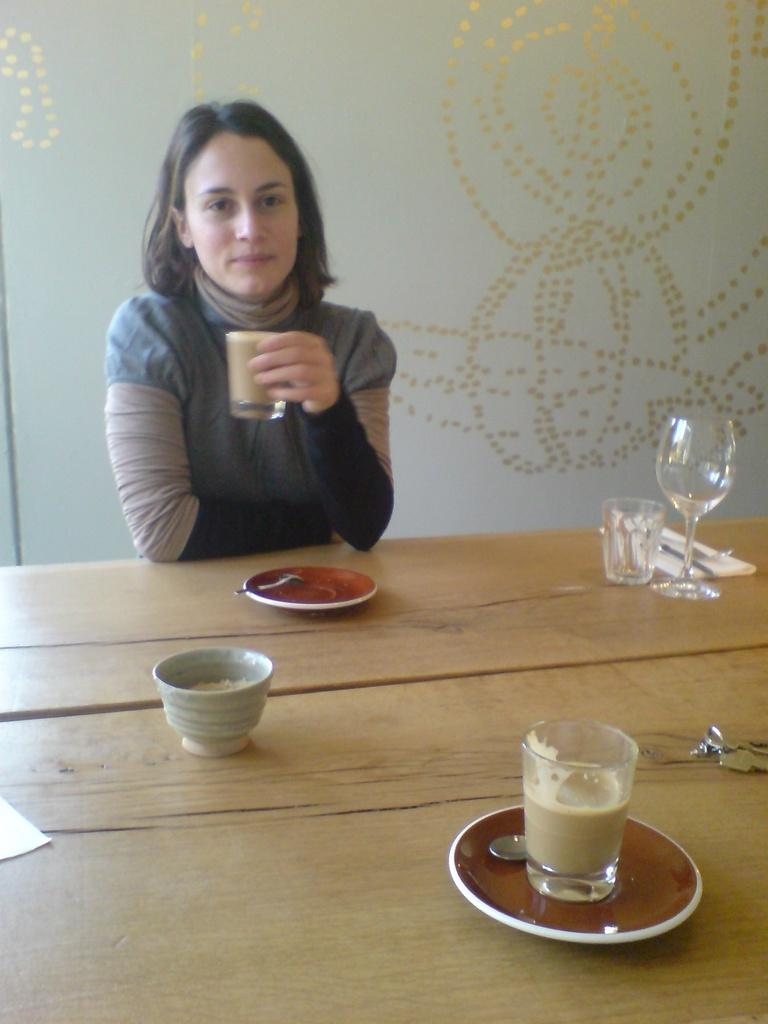Who is present in the image? There is a woman in the image. What is the woman holding in the image? The woman is holding a glass. Where is the woman located in relation to the table? The woman is in front of a table. What can be seen on the table in the image? The table has an empty glass and a cup of drink with a saucer on it. What is visible in the background of the image? There is a wall in the background of the image. What type of lumber is being used to build the prison in the image? There is no prison or lumber present in the image; it features a woman in front of a table with glasses and a cup of drink. What is the best way to escape from the prison in the image? There is no prison present in the image, so it is not possible to discuss the best way to escape from it. 